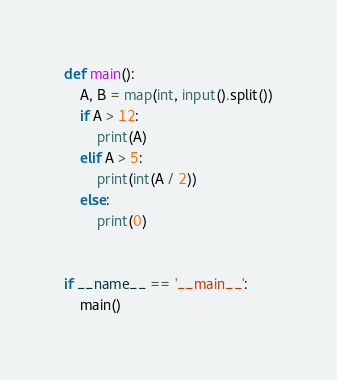<code> <loc_0><loc_0><loc_500><loc_500><_Python_>def main():
    A, B = map(int, input().split())
    if A > 12:
        print(A)
    elif A > 5:
        print(int(A / 2))
    else:
        print(0)


if __name__ == '__main__':
    main()
</code> 